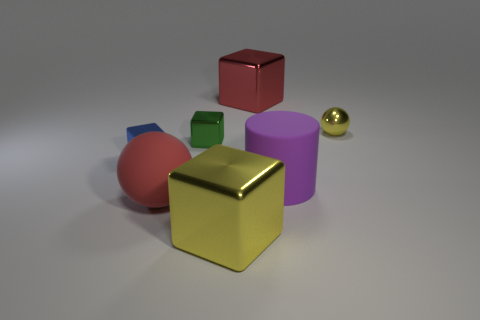Is the number of matte things to the right of the small green metal block greater than the number of yellow blocks?
Provide a short and direct response. No. What number of other objects are there of the same size as the blue thing?
Make the answer very short. 2. What number of things are in front of the small green cube and to the right of the red shiny cube?
Provide a short and direct response. 1. Are the sphere behind the blue block and the tiny green block made of the same material?
Offer a terse response. Yes. There is a big rubber thing to the left of the matte object on the right side of the yellow metallic object in front of the tiny metallic ball; what shape is it?
Provide a succinct answer. Sphere. Are there an equal number of cylinders right of the large cylinder and yellow shiny objects in front of the green metal block?
Ensure brevity in your answer.  No. What is the color of the metal sphere that is the same size as the green object?
Make the answer very short. Yellow. What number of tiny things are either yellow things or balls?
Keep it short and to the point. 1. What is the material of the small thing that is both on the right side of the small blue metallic thing and to the left of the big cylinder?
Your response must be concise. Metal. There is a small thing that is on the right side of the green metallic block; is its shape the same as the metal thing in front of the big red sphere?
Provide a succinct answer. No. 